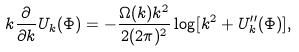Convert formula to latex. <formula><loc_0><loc_0><loc_500><loc_500>k \frac { \partial } { \partial k } U _ { k } ( \Phi ) = - \frac { \Omega ( k ) k ^ { 2 } } { 2 ( 2 \pi ) ^ { 2 } } \log [ k ^ { 2 } + U _ { k } ^ { \prime \prime } ( \Phi ) ] ,</formula> 